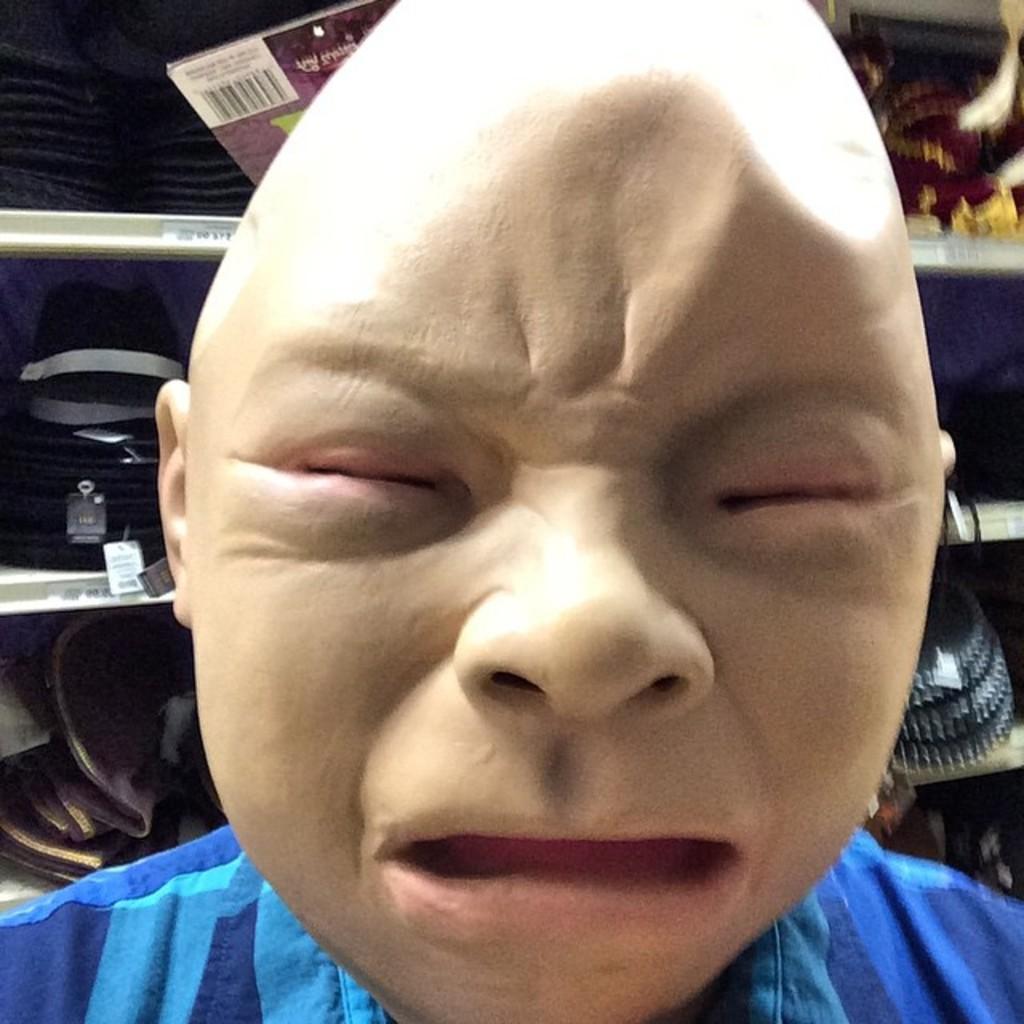How would you summarize this image in a sentence or two? In this image, we can see a person wearing a mask, in the background, we can see a rack and we can see some products kept in the rack. 